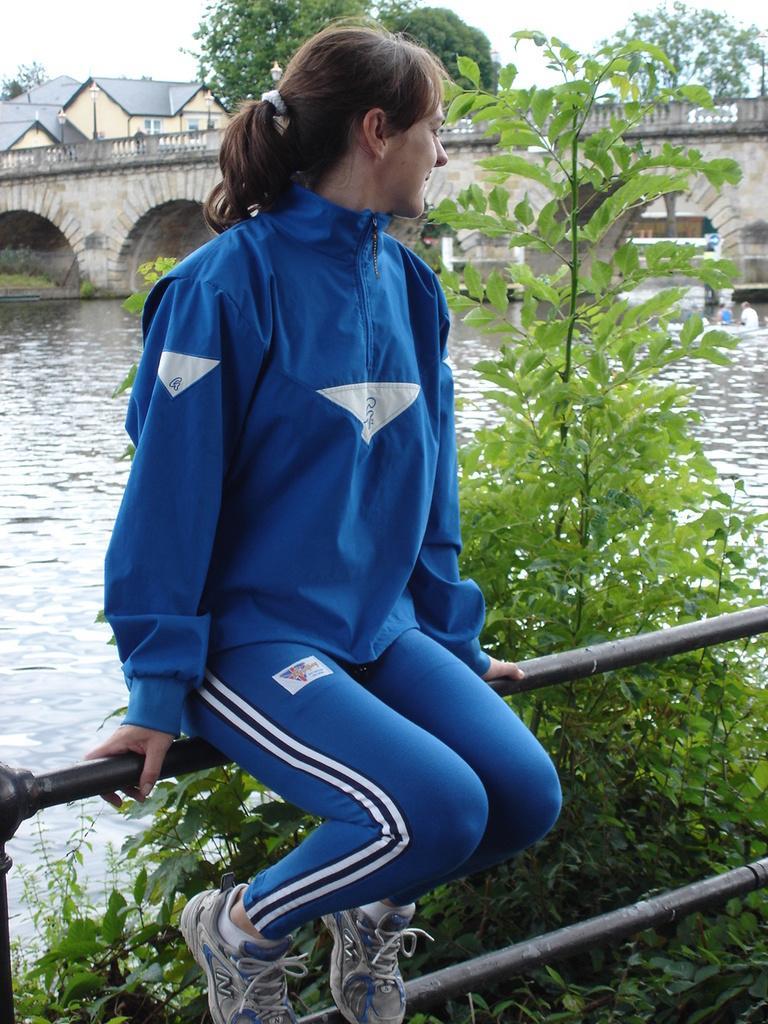Can you describe this image briefly? In the image in the center, we can see one woman sitting. And she is in the blue jacket. In the background, we can see the sky, clouds, buildings, water, trees, plants and one bridge. 